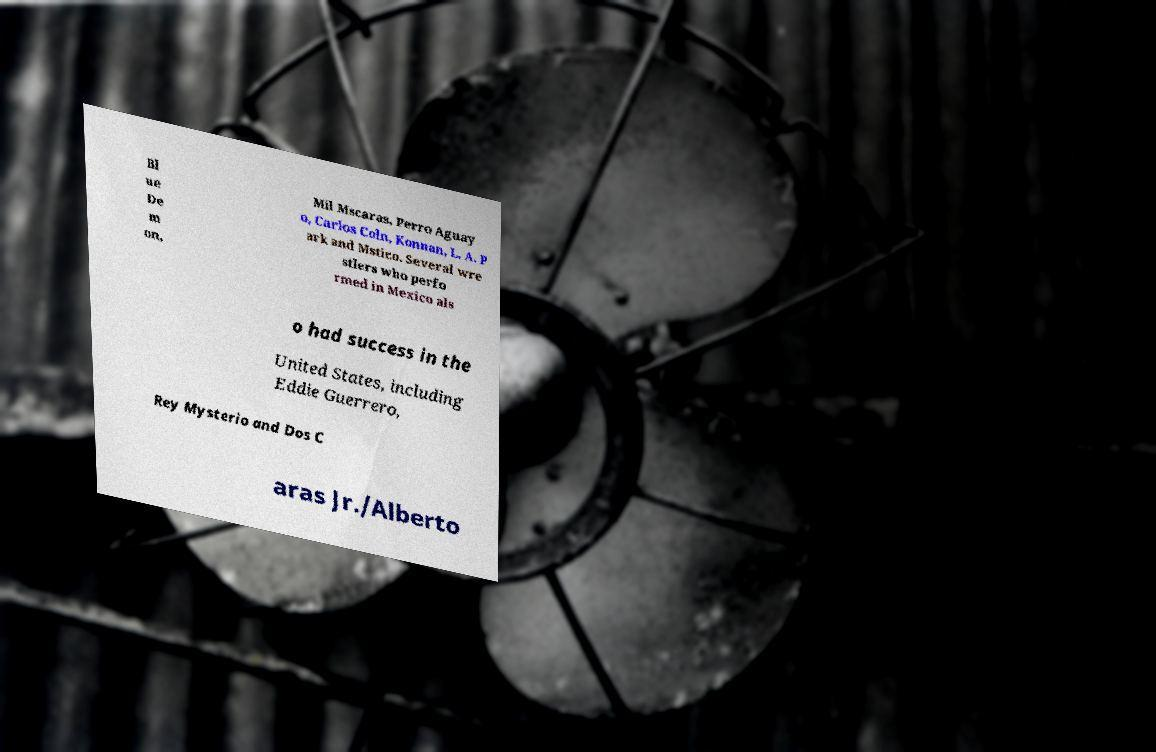Can you accurately transcribe the text from the provided image for me? Bl ue De m on, Mil Mscaras, Perro Aguay o, Carlos Coln, Konnan, L. A. P ark and Mstico. Several wre stlers who perfo rmed in Mexico als o had success in the United States, including Eddie Guerrero, Rey Mysterio and Dos C aras Jr./Alberto 